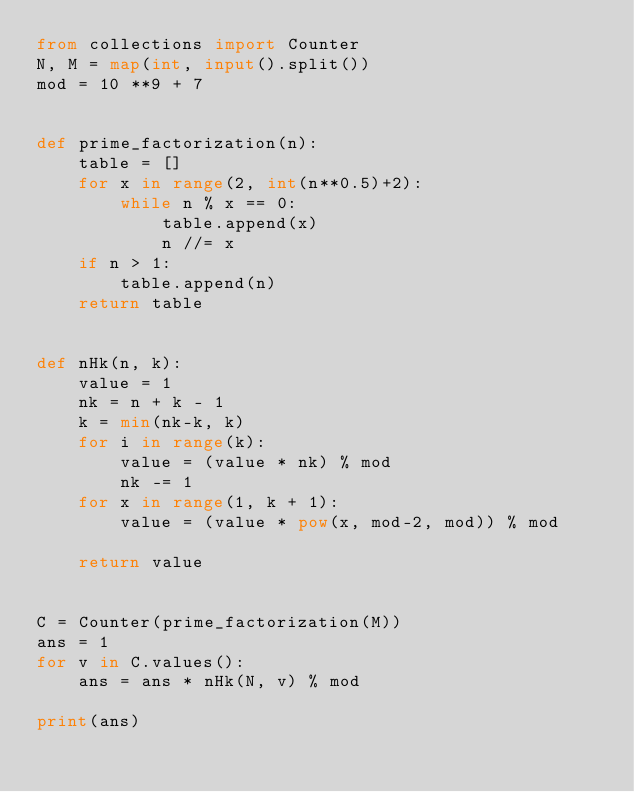Convert code to text. <code><loc_0><loc_0><loc_500><loc_500><_Python_>from collections import Counter
N, M = map(int, input().split())
mod = 10 **9 + 7


def prime_factorization(n):
    table = []
    for x in range(2, int(n**0.5)+2):
        while n % x == 0:
            table.append(x)
            n //= x
    if n > 1:
        table.append(n)
    return table


def nHk(n, k):
    value = 1
    nk = n + k - 1
    k = min(nk-k, k)
    for i in range(k):
        value = (value * nk) % mod
        nk -= 1
    for x in range(1, k + 1):
        value = (value * pow(x, mod-2, mod)) % mod

    return value


C = Counter(prime_factorization(M))
ans = 1
for v in C.values():
    ans = ans * nHk(N, v) % mod

print(ans)
</code> 